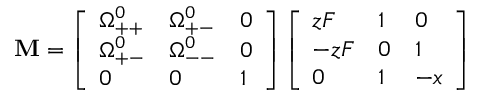Convert formula to latex. <formula><loc_0><loc_0><loc_500><loc_500>M = \left [ \begin{array} { l l l } { \Omega _ { + + } ^ { 0 } } & { \Omega _ { + - } ^ { 0 } } & { 0 } \\ { \Omega _ { + - } ^ { 0 } } & { \Omega _ { - - } ^ { 0 } } & { 0 } \\ { 0 } & { 0 } & { 1 } \end{array} \right ] \left [ \begin{array} { l l l } { z F } & { 1 } & { 0 } \\ { - z F } & { 0 } & { 1 } \\ { 0 } & { 1 } & { - x } \end{array} \right ]</formula> 